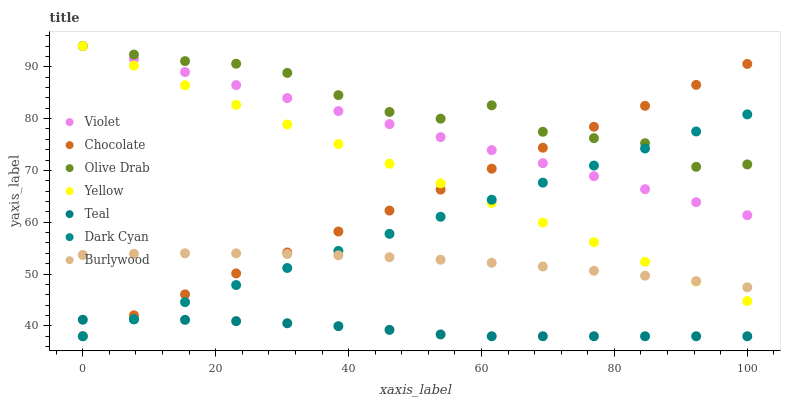Does Teal have the minimum area under the curve?
Answer yes or no. Yes. Does Olive Drab have the maximum area under the curve?
Answer yes or no. Yes. Does Yellow have the minimum area under the curve?
Answer yes or no. No. Does Yellow have the maximum area under the curve?
Answer yes or no. No. Is Violet the smoothest?
Answer yes or no. Yes. Is Olive Drab the roughest?
Answer yes or no. Yes. Is Yellow the smoothest?
Answer yes or no. No. Is Yellow the roughest?
Answer yes or no. No. Does Chocolate have the lowest value?
Answer yes or no. Yes. Does Yellow have the lowest value?
Answer yes or no. No. Does Olive Drab have the highest value?
Answer yes or no. Yes. Does Chocolate have the highest value?
Answer yes or no. No. Is Burlywood less than Violet?
Answer yes or no. Yes. Is Violet greater than Teal?
Answer yes or no. Yes. Does Burlywood intersect Chocolate?
Answer yes or no. Yes. Is Burlywood less than Chocolate?
Answer yes or no. No. Is Burlywood greater than Chocolate?
Answer yes or no. No. Does Burlywood intersect Violet?
Answer yes or no. No. 